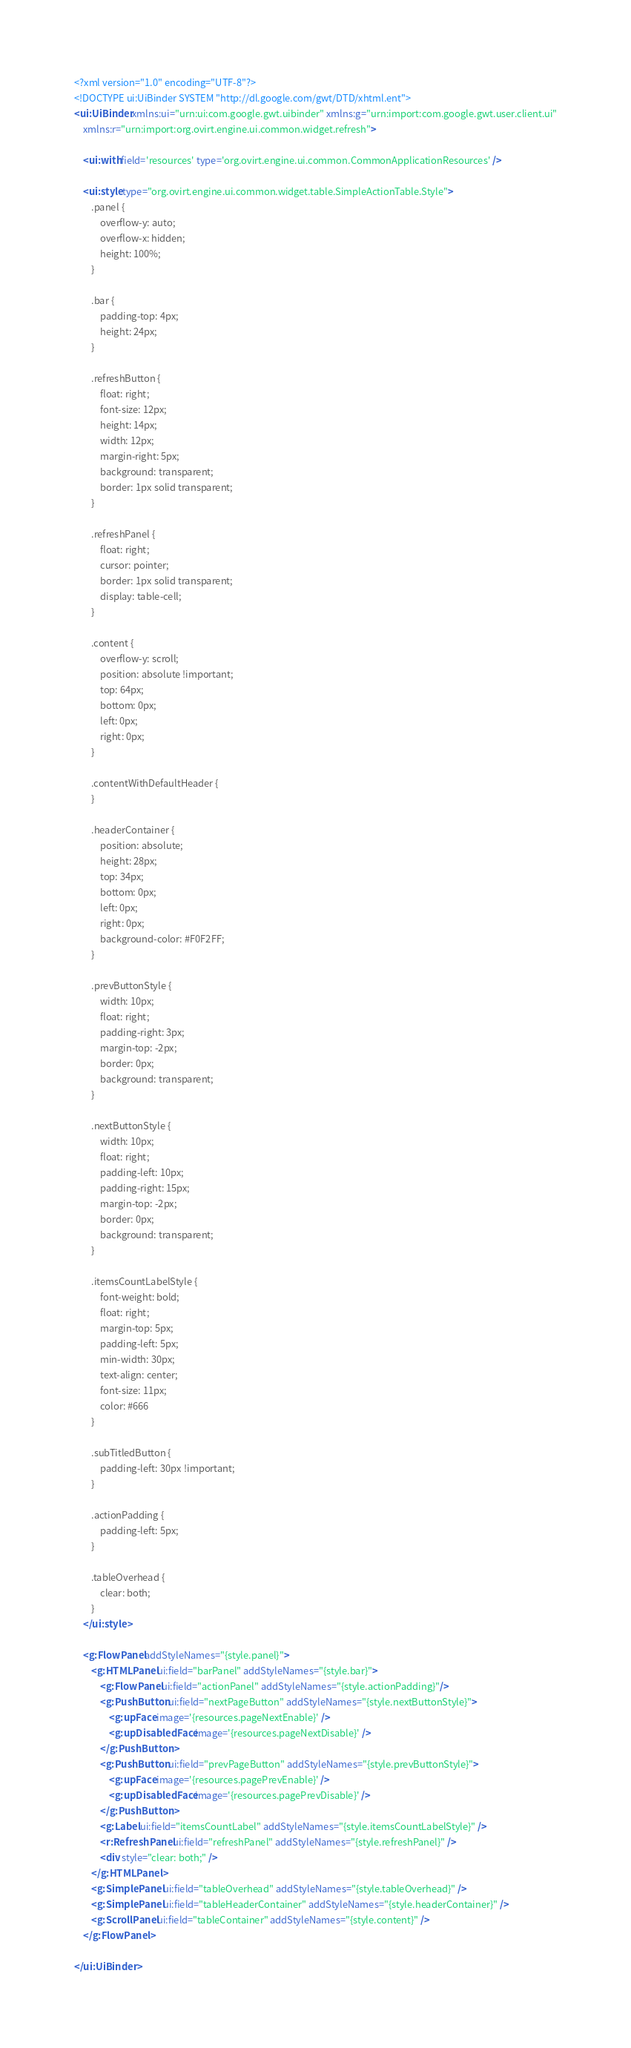<code> <loc_0><loc_0><loc_500><loc_500><_XML_><?xml version="1.0" encoding="UTF-8"?>
<!DOCTYPE ui:UiBinder SYSTEM "http://dl.google.com/gwt/DTD/xhtml.ent">
<ui:UiBinder xmlns:ui="urn:ui:com.google.gwt.uibinder" xmlns:g="urn:import:com.google.gwt.user.client.ui"
    xmlns:r="urn:import:org.ovirt.engine.ui.common.widget.refresh">

    <ui:with field='resources' type='org.ovirt.engine.ui.common.CommonApplicationResources' />

    <ui:style type="org.ovirt.engine.ui.common.widget.table.SimpleActionTable.Style">
        .panel {
            overflow-y: auto;
            overflow-x: hidden;
            height: 100%;
        }

        .bar {
            padding-top: 4px;
            height: 24px;
        }

        .refreshButton {
            float: right;
            font-size: 12px;
            height: 14px;
            width: 12px;
            margin-right: 5px;
            background: transparent;
            border: 1px solid transparent;
        }

        .refreshPanel {
            float: right;
            cursor: pointer;
            border: 1px solid transparent;
            display: table-cell;
        }

        .content {
            overflow-y: scroll;
            position: absolute !important;
            top: 64px;
            bottom: 0px;
            left: 0px;
            right: 0px;
        }

        .contentWithDefaultHeader {
        }

        .headerContainer {
            position: absolute;
            height: 28px;
            top: 34px;
            bottom: 0px;
            left: 0px;
            right: 0px;
            background-color: #F0F2FF;
        }

        .prevButtonStyle {
            width: 10px;
            float: right;
            padding-right: 3px;
            margin-top: -2px;
            border: 0px;
            background: transparent;
        }

        .nextButtonStyle {
            width: 10px;
            float: right;
            padding-left: 10px;
            padding-right: 15px;
            margin-top: -2px;
            border: 0px;
            background: transparent;
        }

        .itemsCountLabelStyle {
            font-weight: bold;
            float: right;
            margin-top: 5px;
            padding-left: 5px;
            min-width: 30px;
            text-align: center;
            font-size: 11px;
            color: #666
        }

        .subTitledButton {
            padding-left: 30px !important;
        }

        .actionPadding {
            padding-left: 5px;
        }

        .tableOverhead {
            clear: both;
        }
    </ui:style>

    <g:FlowPanel addStyleNames="{style.panel}">
        <g:HTMLPanel ui:field="barPanel" addStyleNames="{style.bar}">
            <g:FlowPanel ui:field="actionPanel" addStyleNames="{style.actionPadding}"/>
            <g:PushButton ui:field="nextPageButton" addStyleNames="{style.nextButtonStyle}">
                <g:upFace image='{resources.pageNextEnable}' />
                <g:upDisabledFace image='{resources.pageNextDisable}' />
            </g:PushButton>
            <g:PushButton ui:field="prevPageButton" addStyleNames="{style.prevButtonStyle}">
                <g:upFace image='{resources.pagePrevEnable}' />
                <g:upDisabledFace image='{resources.pagePrevDisable}' />
            </g:PushButton>
            <g:Label ui:field="itemsCountLabel" addStyleNames="{style.itemsCountLabelStyle}" />
            <r:RefreshPanel ui:field="refreshPanel" addStyleNames="{style.refreshPanel}" />
            <div style="clear: both;" />
        </g:HTMLPanel>
        <g:SimplePanel ui:field="tableOverhead" addStyleNames="{style.tableOverhead}" />
        <g:SimplePanel ui:field="tableHeaderContainer" addStyleNames="{style.headerContainer}" />
        <g:ScrollPanel ui:field="tableContainer" addStyleNames="{style.content}" />
    </g:FlowPanel>

</ui:UiBinder>
</code> 